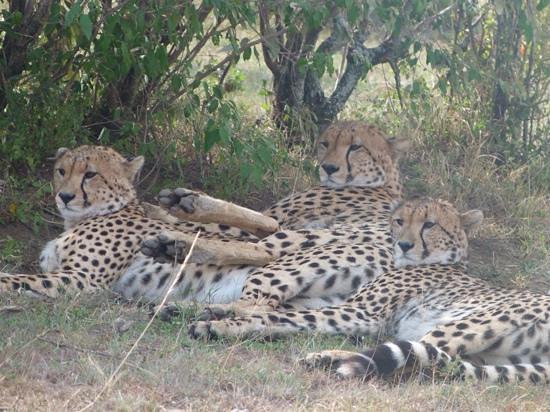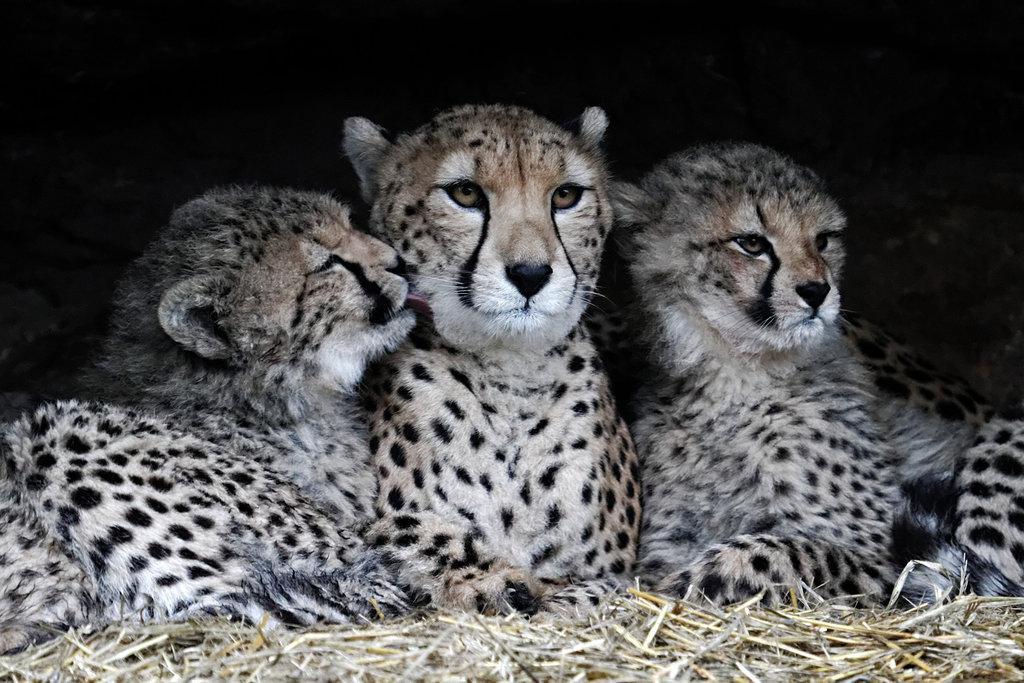The first image is the image on the left, the second image is the image on the right. Assess this claim about the two images: "At least two animals are laying down.". Correct or not? Answer yes or no. Yes. The first image is the image on the left, the second image is the image on the right. Given the left and right images, does the statement "There are three adult cheetahs in one image and three cheetah cubs in the other image." hold true? Answer yes or no. No. 